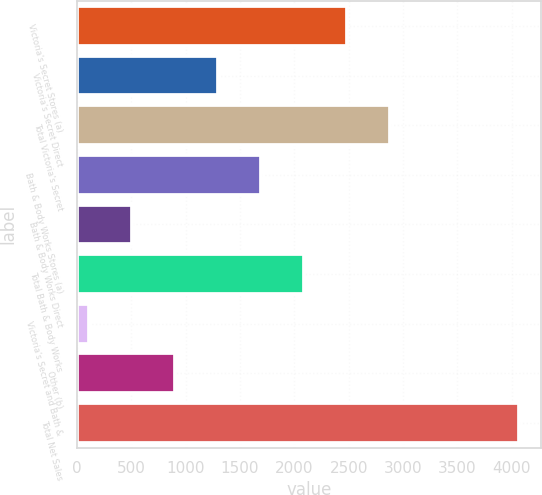<chart> <loc_0><loc_0><loc_500><loc_500><bar_chart><fcel>Victoria's Secret Stores (a)<fcel>Victoria's Secret Direct<fcel>Total Victoria's Secret<fcel>Bath & Body Works Stores (a)<fcel>Bath & Body Works Direct<fcel>Total Bath & Body Works<fcel>Victoria's Secret and Bath &<fcel>Other (b)<fcel>Total Net Sales<nl><fcel>2483.8<fcel>1294.9<fcel>2880.1<fcel>1691.2<fcel>502.3<fcel>2087.5<fcel>106<fcel>898.6<fcel>4069<nl></chart> 